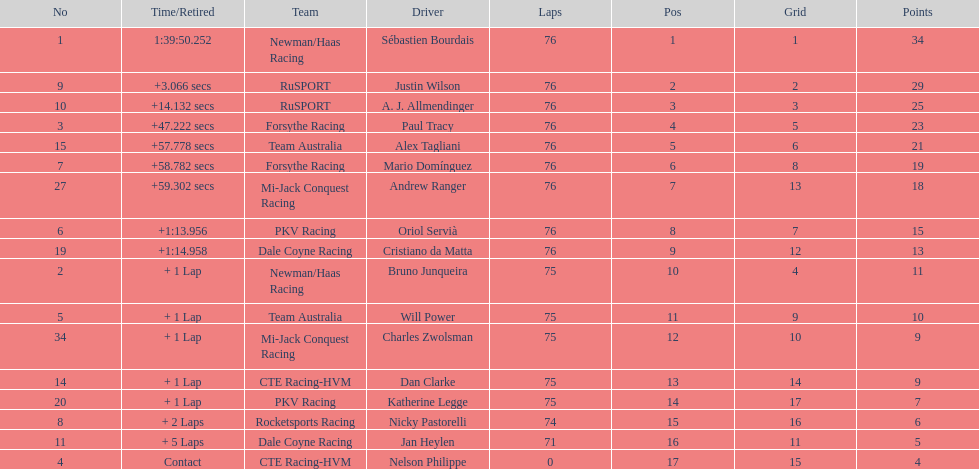Between alex tagliani and paul tracy, which canadian driver came in first place? Paul Tracy. 